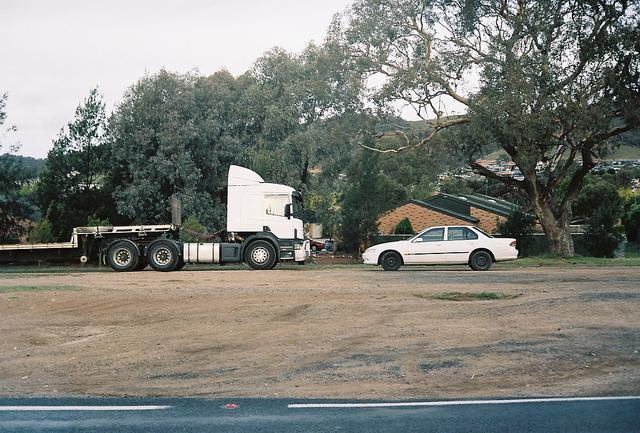What is this type of truck called? semi 